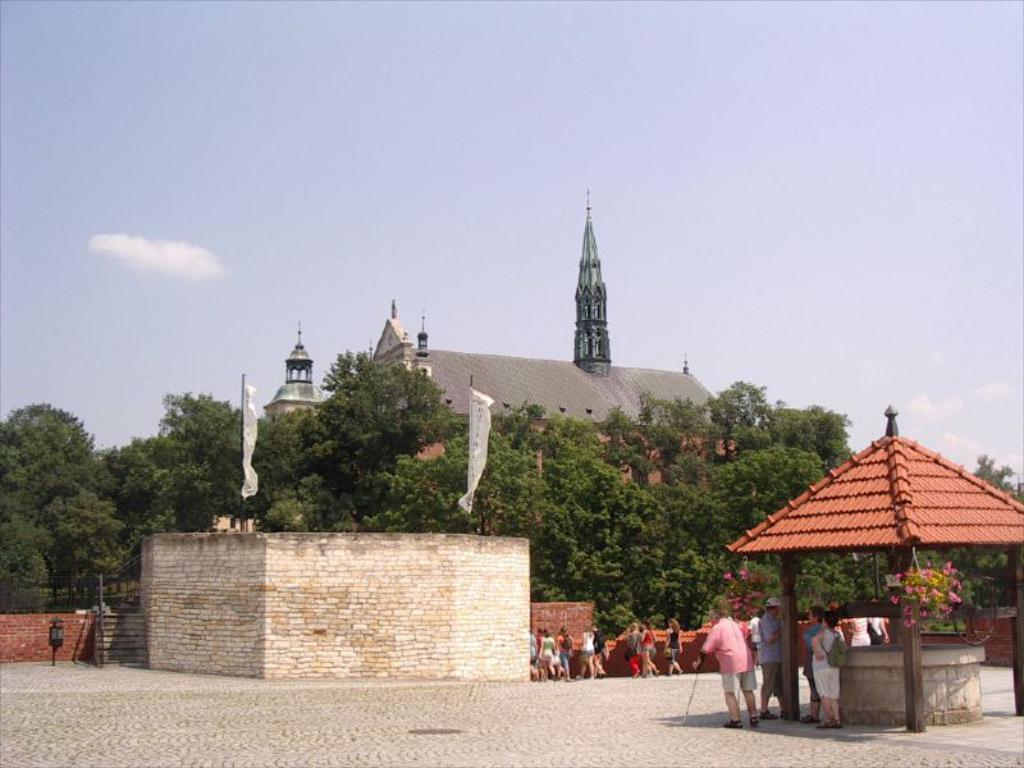Could you give a brief overview of what you see in this image? In this image we can see these people are standing near the well. Here we can see a flower pot hanger. In the background, we can see people walking on the road, trees, brick wall, banners to the pole, building and the sky with clouds. 